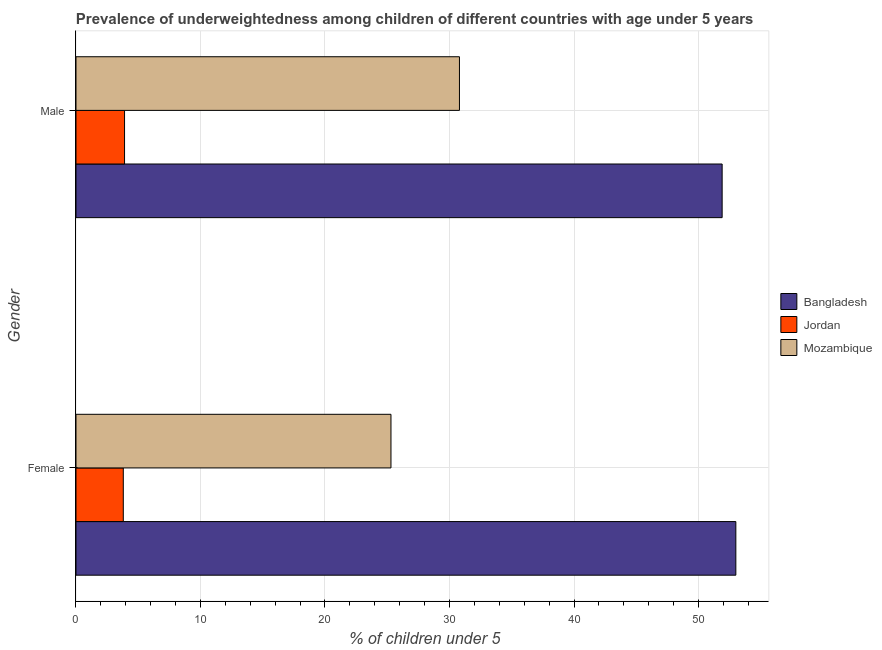How many different coloured bars are there?
Ensure brevity in your answer.  3. How many groups of bars are there?
Make the answer very short. 2. How many bars are there on the 1st tick from the top?
Give a very brief answer. 3. What is the percentage of underweighted female children in Bangladesh?
Keep it short and to the point. 53. Across all countries, what is the maximum percentage of underweighted male children?
Your answer should be very brief. 51.9. Across all countries, what is the minimum percentage of underweighted female children?
Your answer should be compact. 3.8. In which country was the percentage of underweighted female children minimum?
Offer a terse response. Jordan. What is the total percentage of underweighted female children in the graph?
Make the answer very short. 82.1. What is the difference between the percentage of underweighted male children in Jordan and that in Bangladesh?
Your answer should be very brief. -48. What is the difference between the percentage of underweighted female children in Jordan and the percentage of underweighted male children in Mozambique?
Keep it short and to the point. -27. What is the average percentage of underweighted female children per country?
Provide a short and direct response. 27.37. What is the difference between the percentage of underweighted male children and percentage of underweighted female children in Jordan?
Offer a terse response. 0.1. What is the ratio of the percentage of underweighted female children in Mozambique to that in Jordan?
Offer a terse response. 6.66. What does the 2nd bar from the top in Male represents?
Offer a very short reply. Jordan. What does the 3rd bar from the bottom in Male represents?
Offer a terse response. Mozambique. Are all the bars in the graph horizontal?
Your answer should be compact. Yes. How many countries are there in the graph?
Offer a terse response. 3. Are the values on the major ticks of X-axis written in scientific E-notation?
Give a very brief answer. No. Where does the legend appear in the graph?
Provide a succinct answer. Center right. How are the legend labels stacked?
Ensure brevity in your answer.  Vertical. What is the title of the graph?
Offer a very short reply. Prevalence of underweightedness among children of different countries with age under 5 years. Does "Dominica" appear as one of the legend labels in the graph?
Provide a short and direct response. No. What is the label or title of the X-axis?
Your response must be concise.  % of children under 5. What is the label or title of the Y-axis?
Your response must be concise. Gender. What is the  % of children under 5 of Jordan in Female?
Make the answer very short. 3.8. What is the  % of children under 5 of Mozambique in Female?
Ensure brevity in your answer.  25.3. What is the  % of children under 5 of Bangladesh in Male?
Keep it short and to the point. 51.9. What is the  % of children under 5 in Jordan in Male?
Your answer should be compact. 3.9. What is the  % of children under 5 of Mozambique in Male?
Make the answer very short. 30.8. Across all Gender, what is the maximum  % of children under 5 of Jordan?
Provide a short and direct response. 3.9. Across all Gender, what is the maximum  % of children under 5 in Mozambique?
Offer a terse response. 30.8. Across all Gender, what is the minimum  % of children under 5 in Bangladesh?
Keep it short and to the point. 51.9. Across all Gender, what is the minimum  % of children under 5 in Jordan?
Your answer should be very brief. 3.8. Across all Gender, what is the minimum  % of children under 5 of Mozambique?
Ensure brevity in your answer.  25.3. What is the total  % of children under 5 in Bangladesh in the graph?
Keep it short and to the point. 104.9. What is the total  % of children under 5 in Mozambique in the graph?
Ensure brevity in your answer.  56.1. What is the difference between the  % of children under 5 in Jordan in Female and that in Male?
Keep it short and to the point. -0.1. What is the difference between the  % of children under 5 in Bangladesh in Female and the  % of children under 5 in Jordan in Male?
Your answer should be very brief. 49.1. What is the difference between the  % of children under 5 of Bangladesh in Female and the  % of children under 5 of Mozambique in Male?
Provide a succinct answer. 22.2. What is the average  % of children under 5 in Bangladesh per Gender?
Keep it short and to the point. 52.45. What is the average  % of children under 5 of Jordan per Gender?
Provide a succinct answer. 3.85. What is the average  % of children under 5 in Mozambique per Gender?
Give a very brief answer. 28.05. What is the difference between the  % of children under 5 in Bangladesh and  % of children under 5 in Jordan in Female?
Provide a short and direct response. 49.2. What is the difference between the  % of children under 5 in Bangladesh and  % of children under 5 in Mozambique in Female?
Make the answer very short. 27.7. What is the difference between the  % of children under 5 in Jordan and  % of children under 5 in Mozambique in Female?
Your answer should be compact. -21.5. What is the difference between the  % of children under 5 of Bangladesh and  % of children under 5 of Mozambique in Male?
Ensure brevity in your answer.  21.1. What is the difference between the  % of children under 5 in Jordan and  % of children under 5 in Mozambique in Male?
Your answer should be compact. -26.9. What is the ratio of the  % of children under 5 of Bangladesh in Female to that in Male?
Your answer should be compact. 1.02. What is the ratio of the  % of children under 5 in Jordan in Female to that in Male?
Offer a terse response. 0.97. What is the ratio of the  % of children under 5 in Mozambique in Female to that in Male?
Ensure brevity in your answer.  0.82. What is the difference between the highest and the second highest  % of children under 5 of Bangladesh?
Offer a terse response. 1.1. What is the difference between the highest and the second highest  % of children under 5 of Mozambique?
Your answer should be very brief. 5.5. What is the difference between the highest and the lowest  % of children under 5 in Bangladesh?
Make the answer very short. 1.1. 